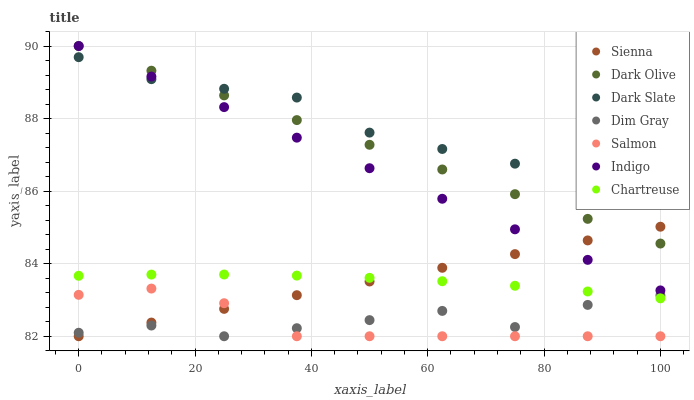Does Salmon have the minimum area under the curve?
Answer yes or no. Yes. Does Dark Slate have the maximum area under the curve?
Answer yes or no. Yes. Does Indigo have the minimum area under the curve?
Answer yes or no. No. Does Indigo have the maximum area under the curve?
Answer yes or no. No. Is Indigo the smoothest?
Answer yes or no. Yes. Is Dim Gray the roughest?
Answer yes or no. Yes. Is Dark Olive the smoothest?
Answer yes or no. No. Is Dark Olive the roughest?
Answer yes or no. No. Does Dim Gray have the lowest value?
Answer yes or no. Yes. Does Indigo have the lowest value?
Answer yes or no. No. Does Dark Olive have the highest value?
Answer yes or no. Yes. Does Salmon have the highest value?
Answer yes or no. No. Is Chartreuse less than Dark Slate?
Answer yes or no. Yes. Is Indigo greater than Salmon?
Answer yes or no. Yes. Does Salmon intersect Dim Gray?
Answer yes or no. Yes. Is Salmon less than Dim Gray?
Answer yes or no. No. Is Salmon greater than Dim Gray?
Answer yes or no. No. Does Chartreuse intersect Dark Slate?
Answer yes or no. No. 